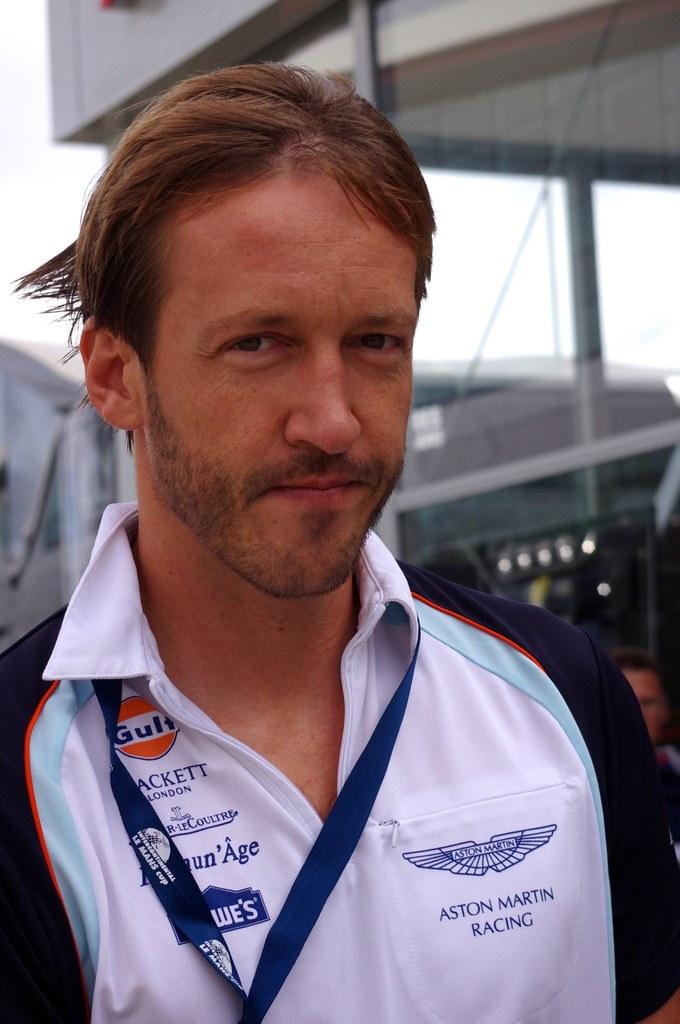Which racing team is he part of?
Provide a short and direct response. Aston martin. What hardware store is mentioned on his shirt?
Your answer should be compact. Lowe's. 